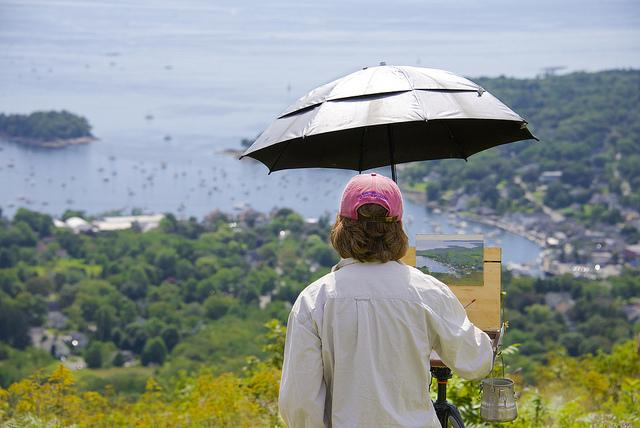What is in the metal tin? Please explain your reasoning. water. There is water, most likely to clean up the paint off the brush. 